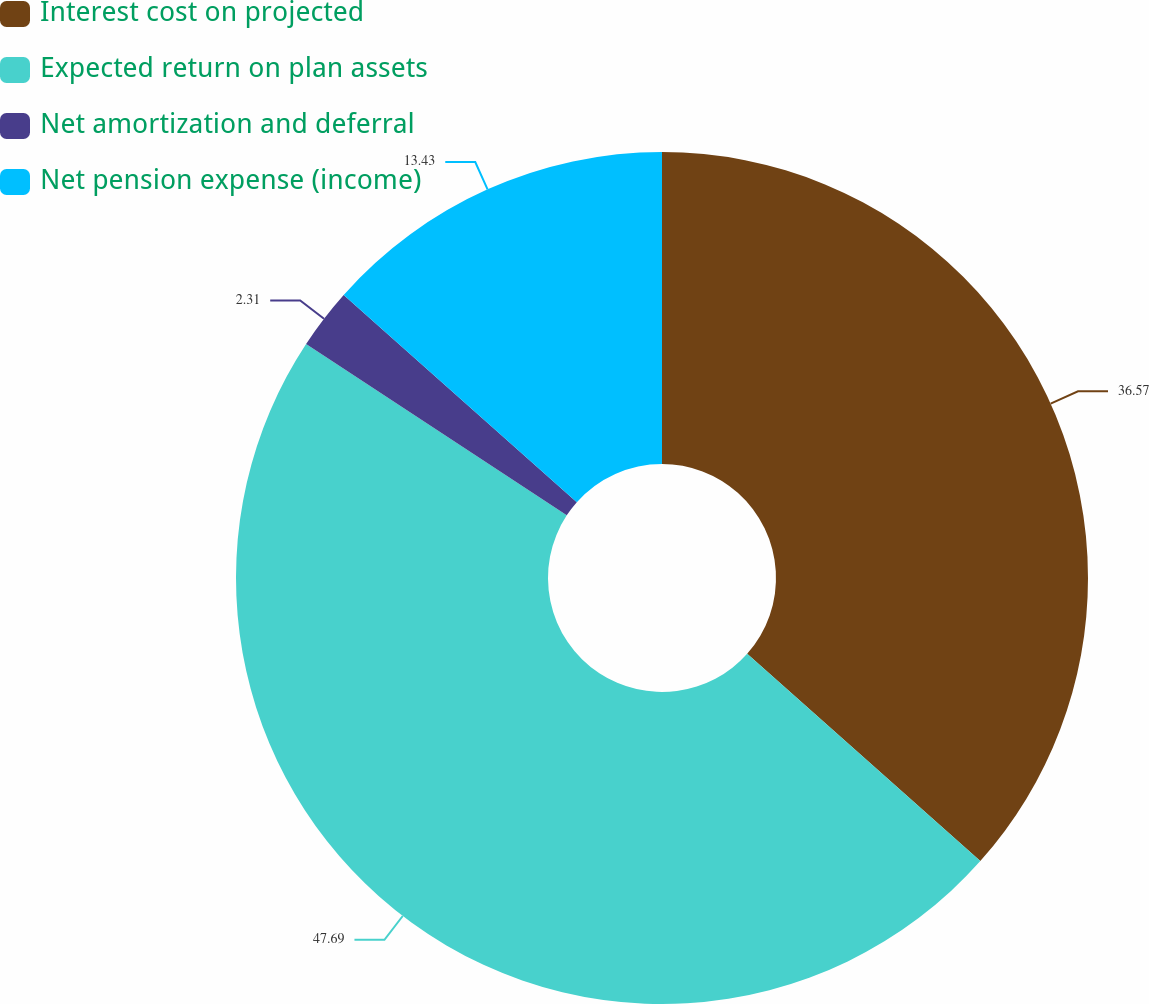<chart> <loc_0><loc_0><loc_500><loc_500><pie_chart><fcel>Interest cost on projected<fcel>Expected return on plan assets<fcel>Net amortization and deferral<fcel>Net pension expense (income)<nl><fcel>36.57%<fcel>47.69%<fcel>2.31%<fcel>13.43%<nl></chart> 